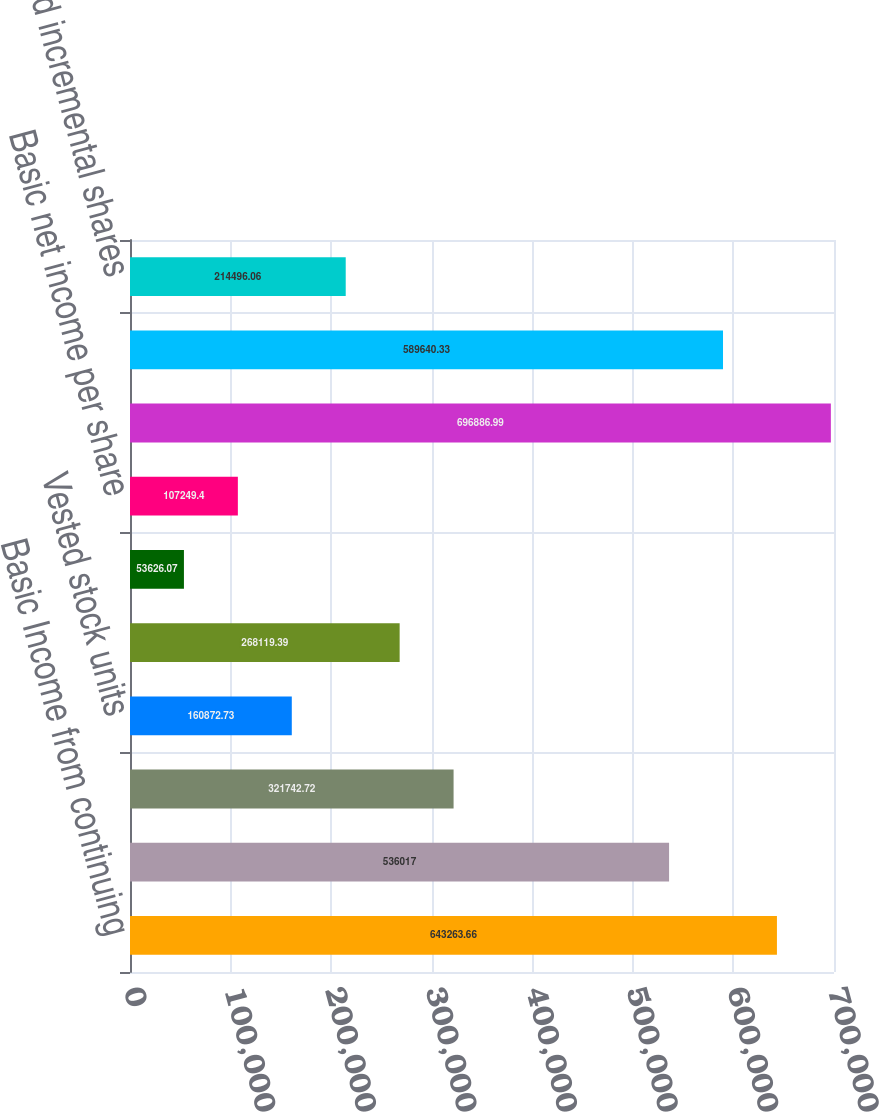Convert chart to OTSL. <chart><loc_0><loc_0><loc_500><loc_500><bar_chart><fcel>Basic Income from continuing<fcel>Inc Net income attributable to<fcel>Weighted average shares<fcel>Vested stock units<fcel>Weighted average shares for<fcel>Basic income from continuing<fcel>Basic net income per share<fcel>Income from continuing<fcel>Net income attributable to<fcel>Assumed incremental shares<nl><fcel>643264<fcel>536017<fcel>321743<fcel>160873<fcel>268119<fcel>53626.1<fcel>107249<fcel>696887<fcel>589640<fcel>214496<nl></chart> 